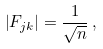<formula> <loc_0><loc_0><loc_500><loc_500>\left | F _ { j k } \right | = \frac { 1 } { \sqrt { n } } \, ,</formula> 